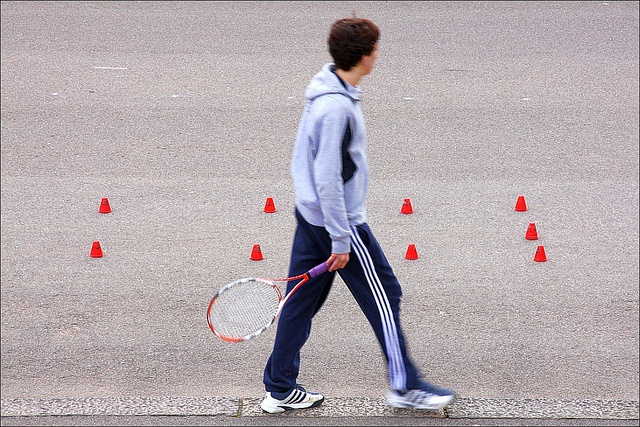Describe the objects in this image and their specific colors. I can see people in black, lavender, darkgray, and navy tones and tennis racket in black, lightgray, darkgray, pink, and navy tones in this image. 